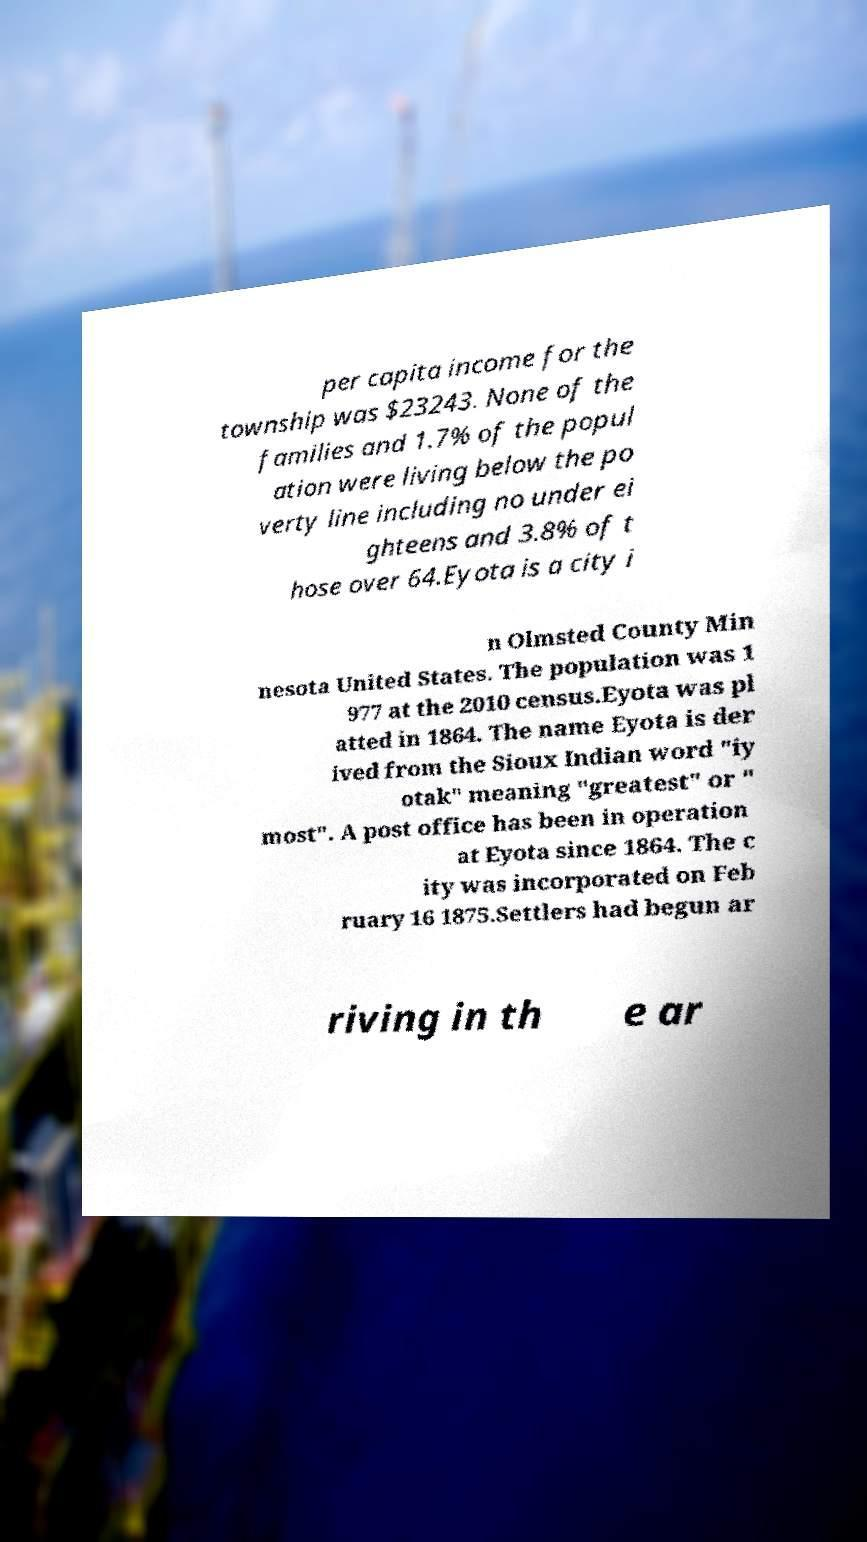Please identify and transcribe the text found in this image. per capita income for the township was $23243. None of the families and 1.7% of the popul ation were living below the po verty line including no under ei ghteens and 3.8% of t hose over 64.Eyota is a city i n Olmsted County Min nesota United States. The population was 1 977 at the 2010 census.Eyota was pl atted in 1864. The name Eyota is der ived from the Sioux Indian word "iy otak" meaning "greatest" or " most". A post office has been in operation at Eyota since 1864. The c ity was incorporated on Feb ruary 16 1875.Settlers had begun ar riving in th e ar 